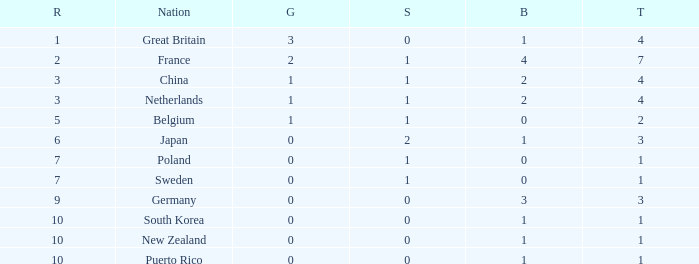What is the rank with 0 bronze? None. 